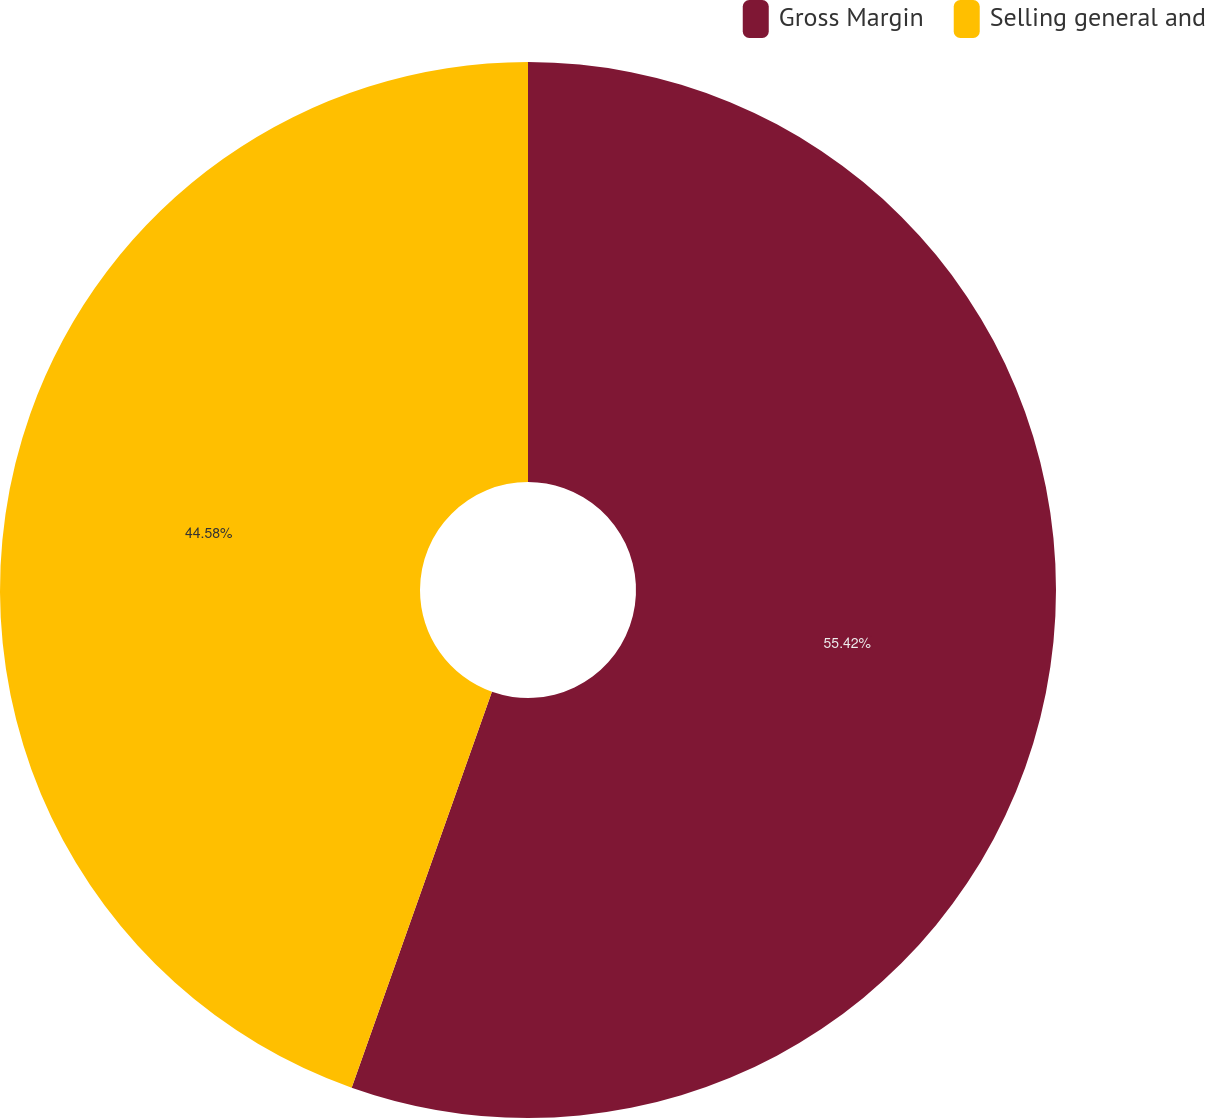Convert chart to OTSL. <chart><loc_0><loc_0><loc_500><loc_500><pie_chart><fcel>Gross Margin<fcel>Selling general and<nl><fcel>55.42%<fcel>44.58%<nl></chart> 